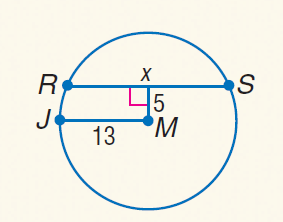Question: Find x.
Choices:
A. 5
B. 12
C. 24
D. 26
Answer with the letter. Answer: C 